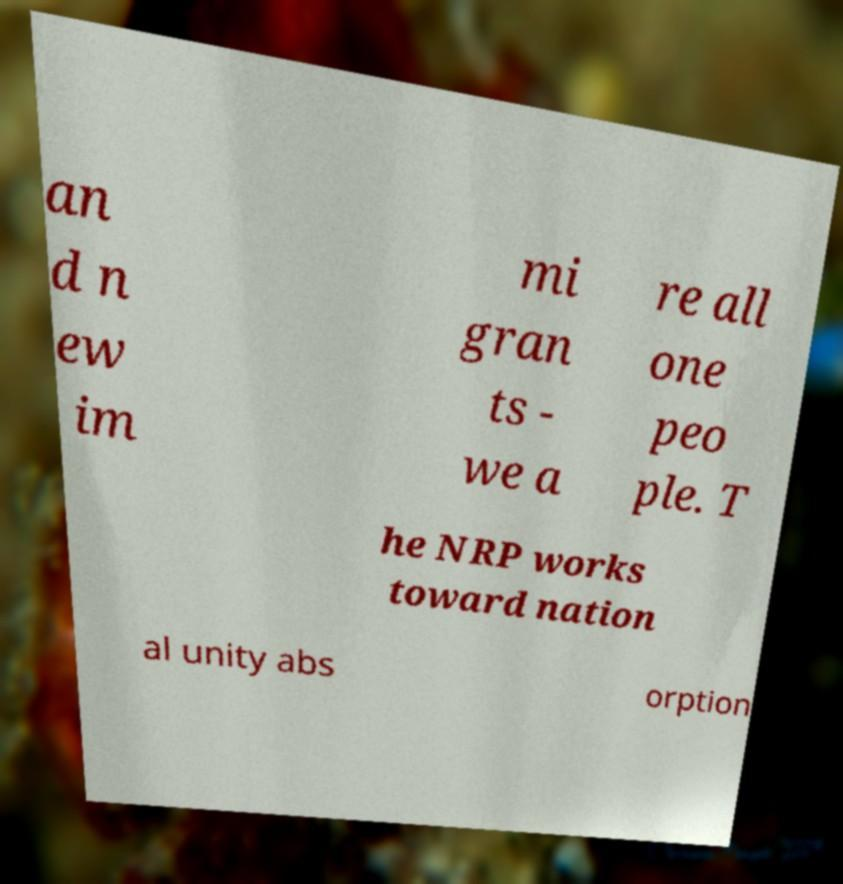Please read and relay the text visible in this image. What does it say? an d n ew im mi gran ts - we a re all one peo ple. T he NRP works toward nation al unity abs orption 